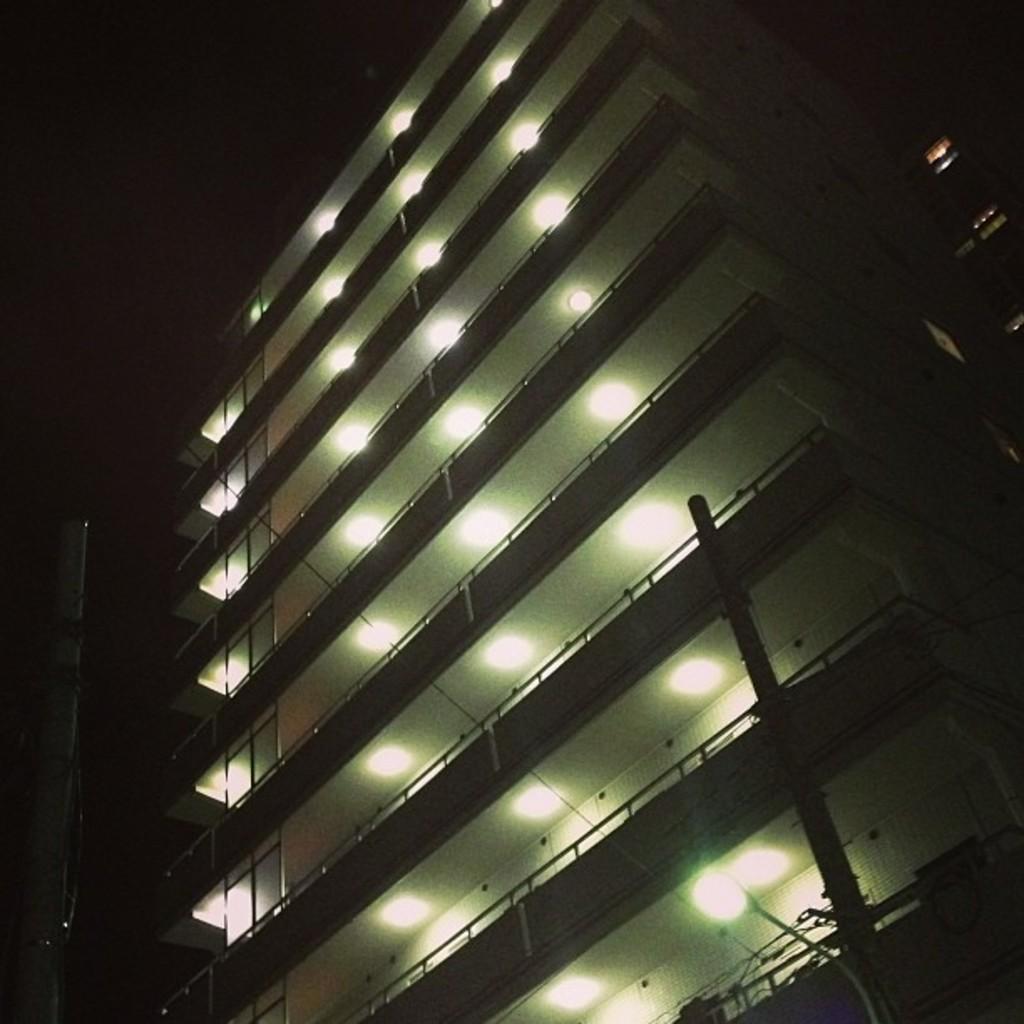Can you describe this image briefly? In this image I can see at the bottom there is a street lamp. In the middle it looks like a very big building, there are ceiling lights to it. On the left side it looks like a sky in the dark knight. 